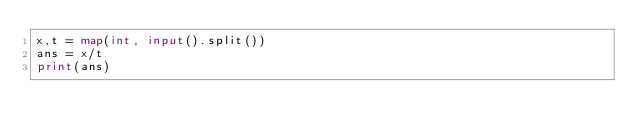Convert code to text. <code><loc_0><loc_0><loc_500><loc_500><_Python_>x,t = map(int, input().split())
ans = x/t
print(ans)</code> 